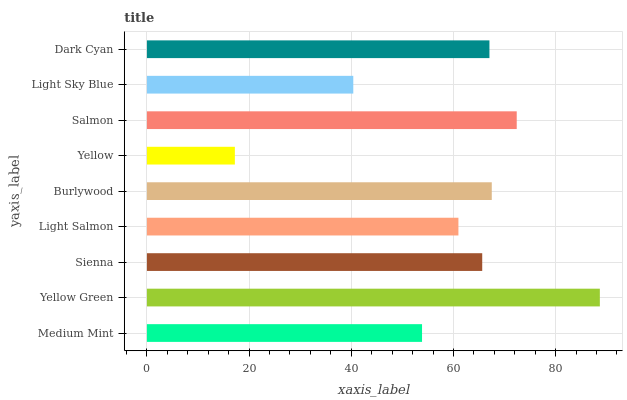Is Yellow the minimum?
Answer yes or no. Yes. Is Yellow Green the maximum?
Answer yes or no. Yes. Is Sienna the minimum?
Answer yes or no. No. Is Sienna the maximum?
Answer yes or no. No. Is Yellow Green greater than Sienna?
Answer yes or no. Yes. Is Sienna less than Yellow Green?
Answer yes or no. Yes. Is Sienna greater than Yellow Green?
Answer yes or no. No. Is Yellow Green less than Sienna?
Answer yes or no. No. Is Sienna the high median?
Answer yes or no. Yes. Is Sienna the low median?
Answer yes or no. Yes. Is Dark Cyan the high median?
Answer yes or no. No. Is Burlywood the low median?
Answer yes or no. No. 